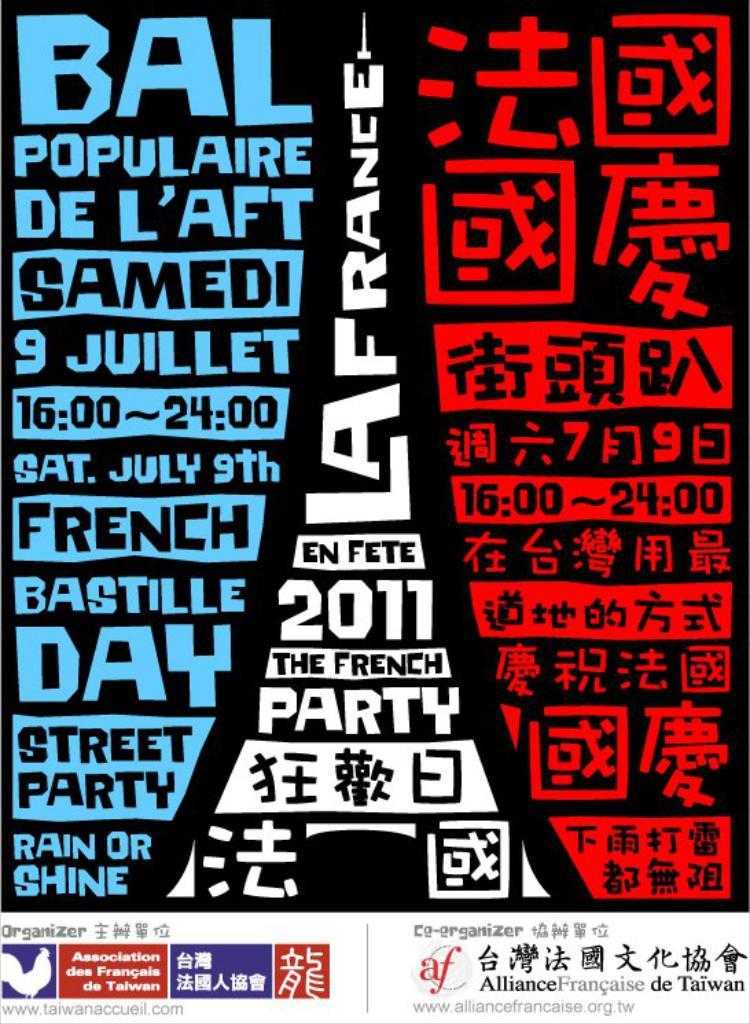What is present on the poster in the image? There is a poster in the image that contains text and symbols. Can you describe the text on the poster? Unfortunately, the specific content of the text cannot be determined from the image alone. What type of symbols are present on the poster? The image does not provide enough detail to identify the specific symbols on the poster. What type of glass is being used to support the chin of the person in the image? There is no person or chin present in the image; it only contains a poster with text and symbols. 